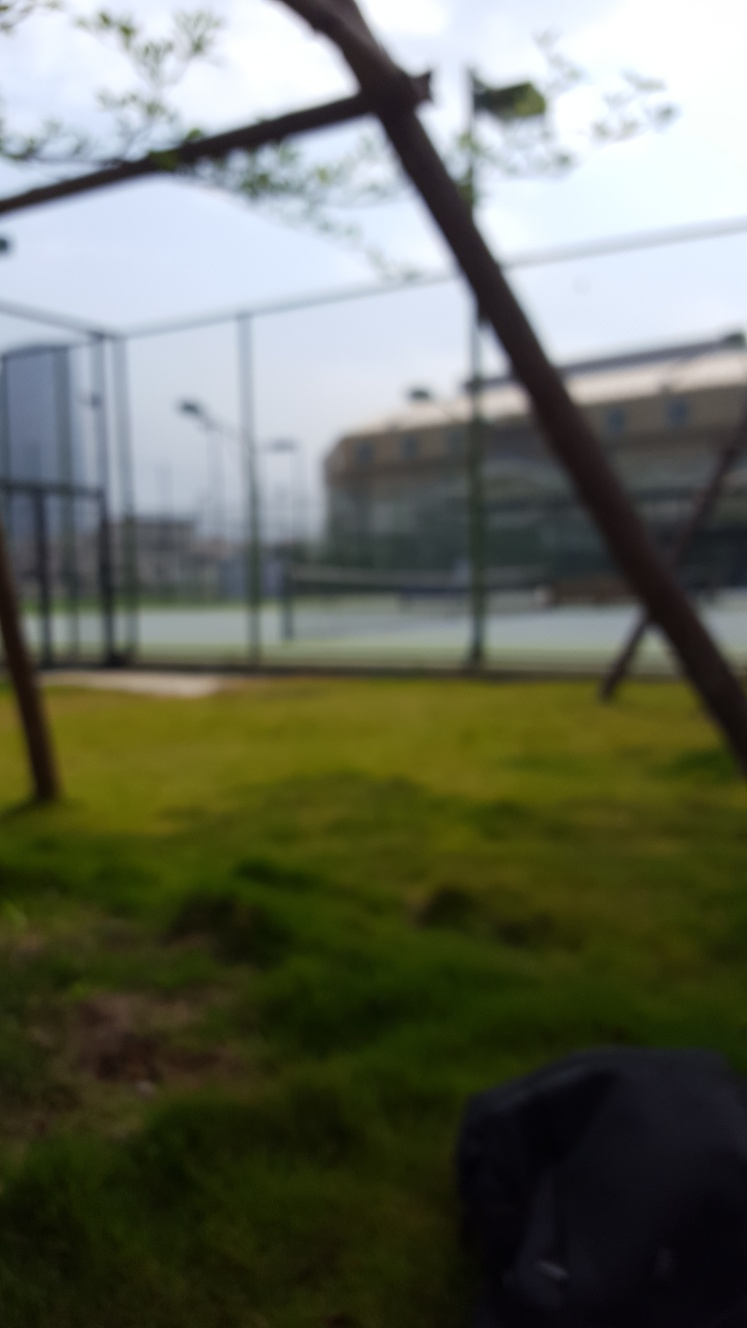What is the texture detail in this image? The texture detail in the image is challenging to discern due to the blurred nature of the photograph, which obscures fine details and makes textures indistinct. The focus seems to be shifted away from any specific elements, resulting in a loss of sharpness across the entire image. 